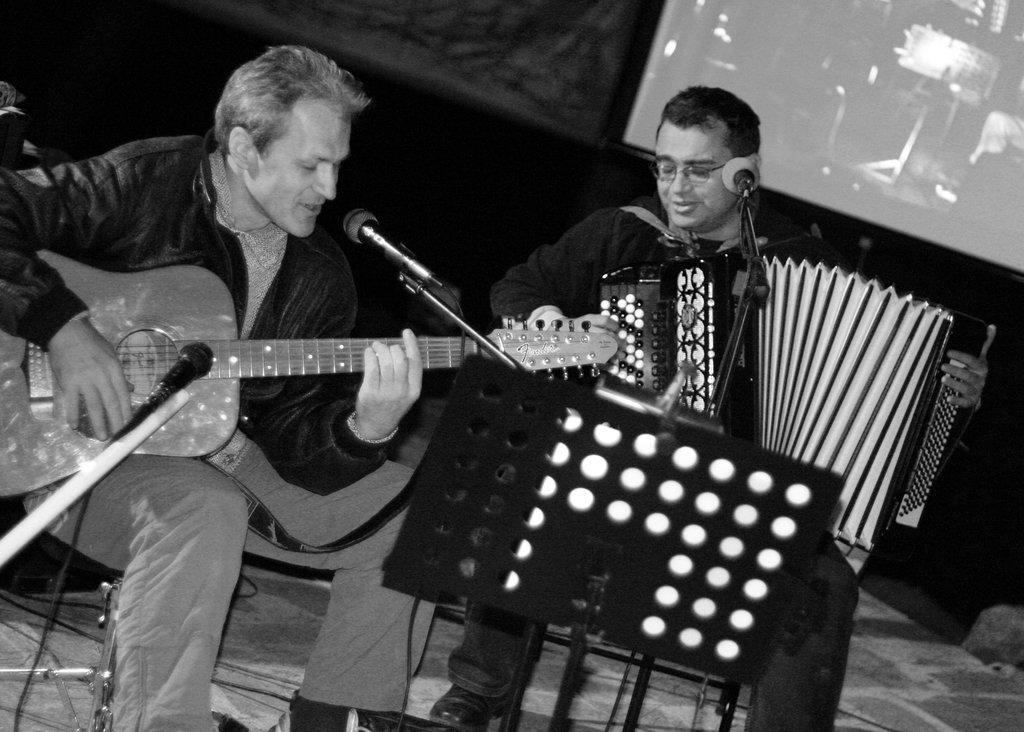How would you summarize this image in a sentence or two? They both are sitting on a chair. They are playing musical instruments. 